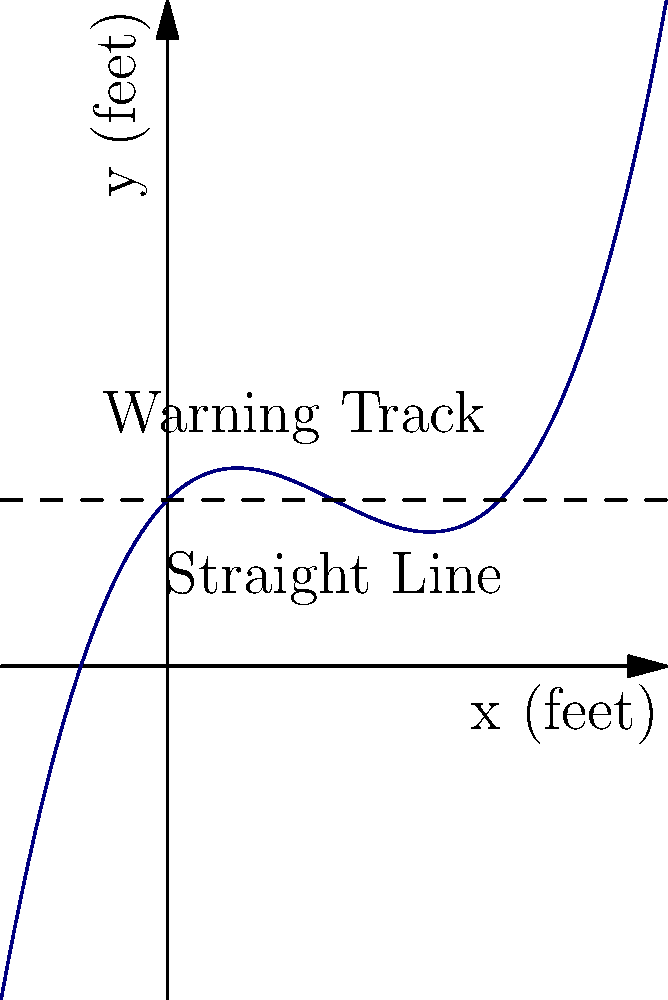The curvature of a baseball field's warning track can be modeled by the polynomial function $f(x) = 0.005x^3 - 0.15x^2 + x + 10$, where $x$ and $f(x)$ are measured in feet. How does the actual warning track (blue curve) compare to a straight line (dashed) at $x = 20$ feet? To compare the actual warning track to a straight line at $x = 20$ feet, we need to follow these steps:

1) First, calculate the y-value of the actual warning track at $x = 20$:
   $f(20) = 0.005(20)^3 - 0.15(20)^2 + 20 + 10$
   $= 0.005(8000) - 0.15(400) + 20 + 10$
   $= 40 - 60 + 20 + 10$
   $= 10$ feet

2) The straight line is represented by $y = 10$ (the dashed line in the graph).

3) At $x = 20$, both the actual warning track and the straight line have a y-value of 10 feet.

4) Looking at the graph, we can see that before $x = 20$, the actual warning track is above the straight line, and after $x = 20$, it's below the straight line.

5) This means that $x = 20$ is approximately where the actual warning track crosses the straight line, changing from being above it to below it.

Therefore, at $x = 20$ feet, the actual warning track intersects with the straight line, marking a transition point in its curvature.
Answer: Intersects and transitions from above to below the straight line 